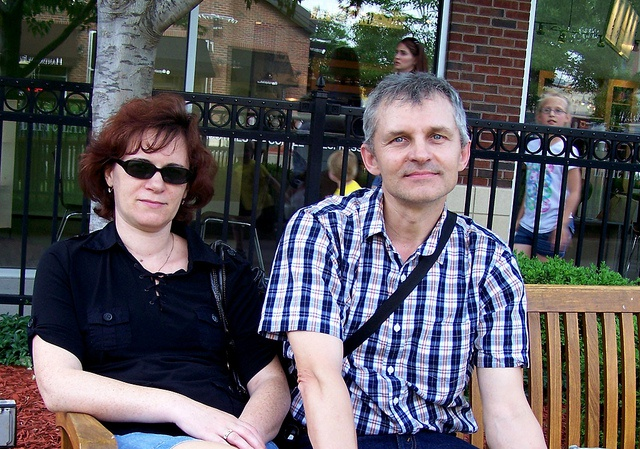Describe the objects in this image and their specific colors. I can see people in black, lightgray, navy, and darkgray tones, people in black, lightgray, pink, and maroon tones, bench in black, tan, and gray tones, people in black, darkgray, and gray tones, and handbag in black and gray tones in this image. 